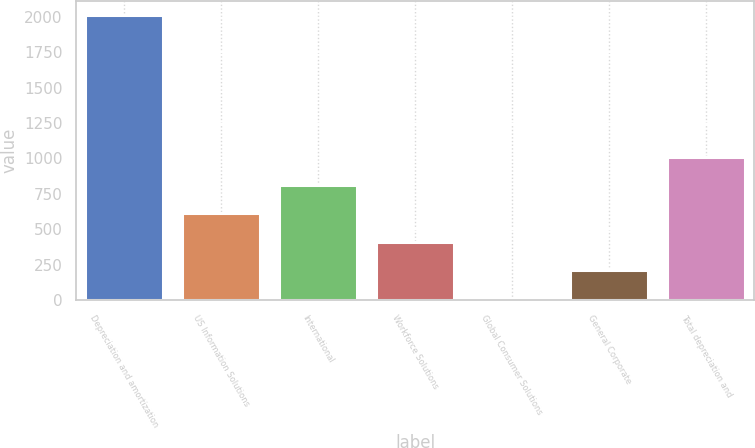Convert chart to OTSL. <chart><loc_0><loc_0><loc_500><loc_500><bar_chart><fcel>Depreciation and amortization<fcel>US Information Solutions<fcel>International<fcel>Workforce Solutions<fcel>Global Consumer Solutions<fcel>General Corporate<fcel>Total depreciation and<nl><fcel>2016<fcel>611.52<fcel>812.16<fcel>410.88<fcel>9.6<fcel>210.24<fcel>1012.8<nl></chart> 